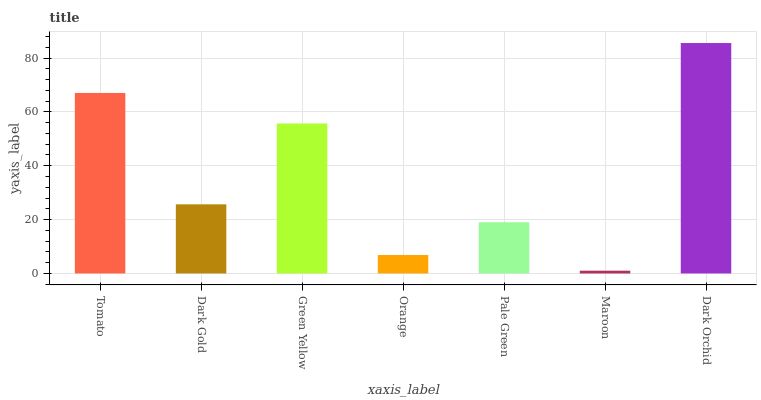Is Dark Gold the minimum?
Answer yes or no. No. Is Dark Gold the maximum?
Answer yes or no. No. Is Tomato greater than Dark Gold?
Answer yes or no. Yes. Is Dark Gold less than Tomato?
Answer yes or no. Yes. Is Dark Gold greater than Tomato?
Answer yes or no. No. Is Tomato less than Dark Gold?
Answer yes or no. No. Is Dark Gold the high median?
Answer yes or no. Yes. Is Dark Gold the low median?
Answer yes or no. Yes. Is Pale Green the high median?
Answer yes or no. No. Is Pale Green the low median?
Answer yes or no. No. 